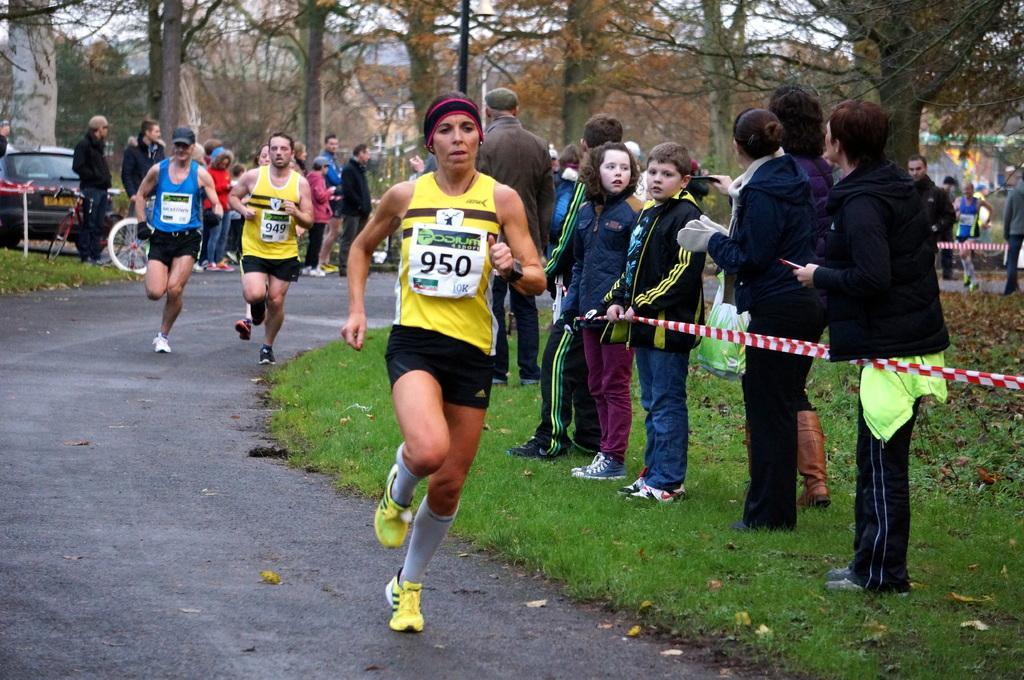Describe this image in one or two sentences. In this picture I can see the road in front, on which there are few people running and I can see few more people standing on the grass. In the background I can see a car and number of trees. 